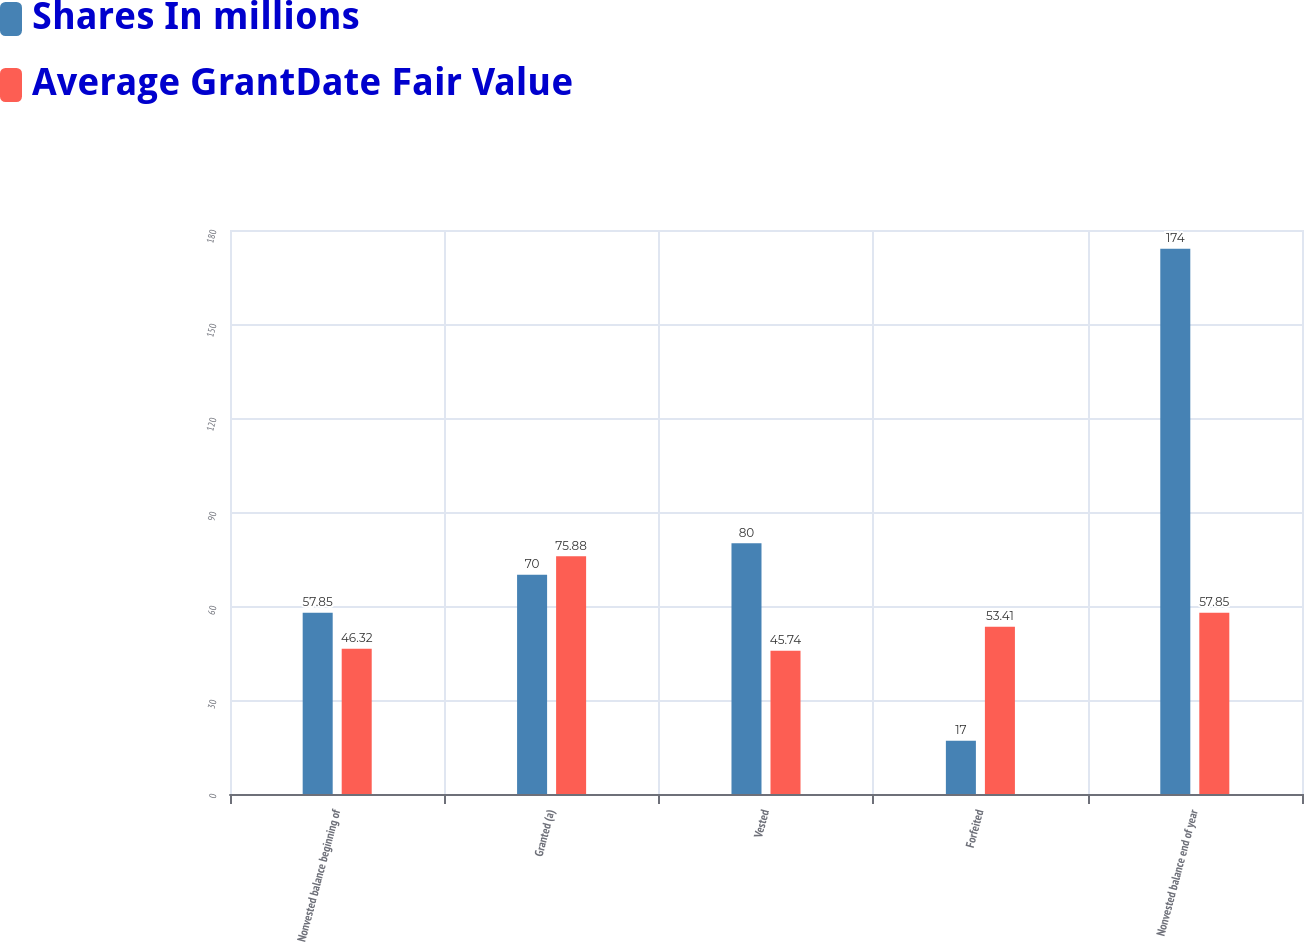Convert chart to OTSL. <chart><loc_0><loc_0><loc_500><loc_500><stacked_bar_chart><ecel><fcel>Nonvested balance beginning of<fcel>Granted (a)<fcel>Vested<fcel>Forfeited<fcel>Nonvested balance end of year<nl><fcel>Shares In millions<fcel>57.85<fcel>70<fcel>80<fcel>17<fcel>174<nl><fcel>Average GrantDate Fair Value<fcel>46.32<fcel>75.88<fcel>45.74<fcel>53.41<fcel>57.85<nl></chart> 